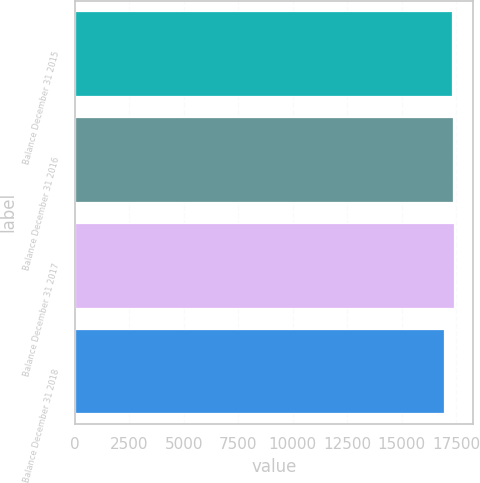<chart> <loc_0><loc_0><loc_500><loc_500><bar_chart><fcel>Balance December 31 2015<fcel>Balance December 31 2016<fcel>Balance December 31 2017<fcel>Balance December 31 2018<nl><fcel>17333<fcel>17377.6<fcel>17422.2<fcel>16937<nl></chart> 